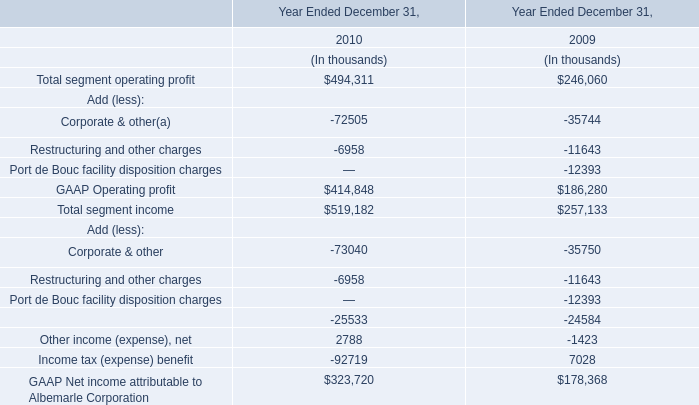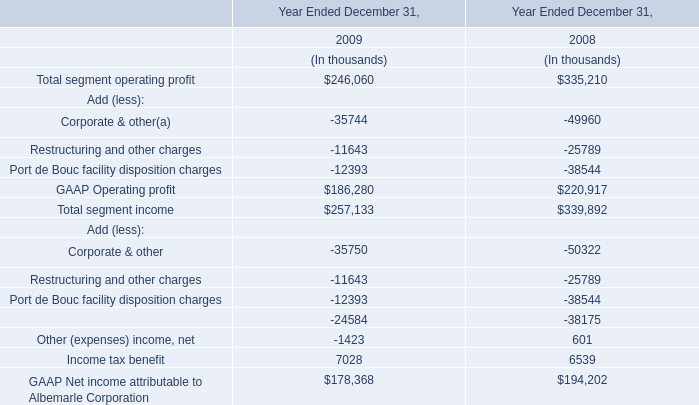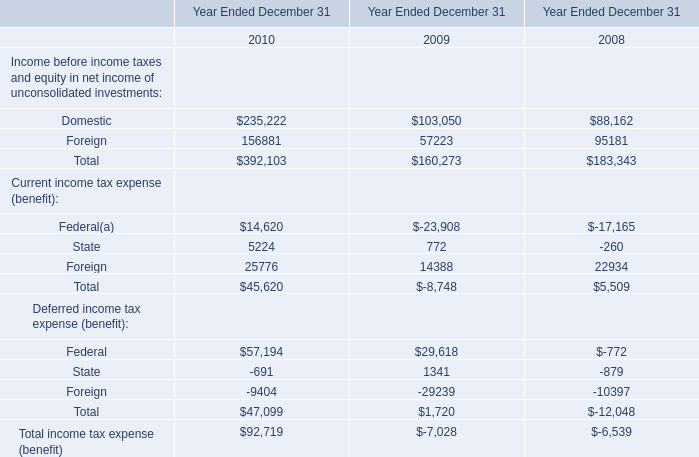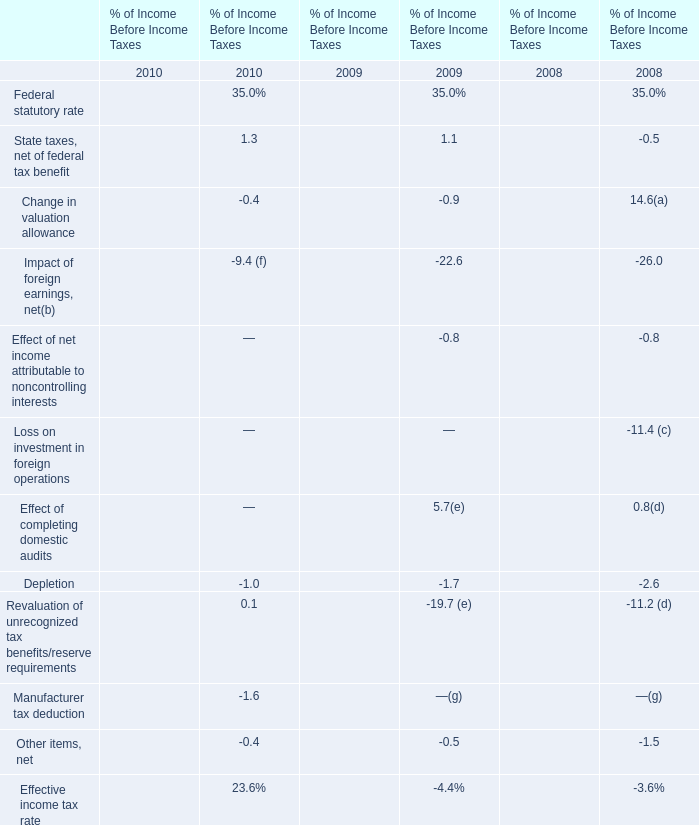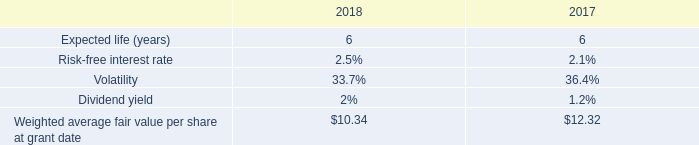In the year with largest amount of Income before income taxes and equity in net income of unconsolidated investments, what's the increasing rate of Deferred income tax expense? 
Computations: ((47099 - 1720) / 1720)
Answer: 26.38314. 